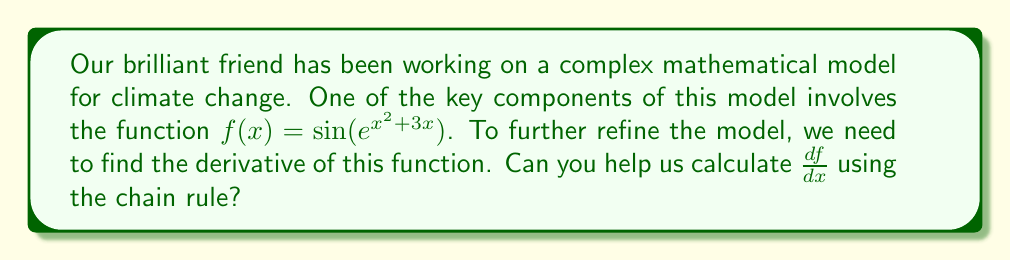Teach me how to tackle this problem. Let's approach this step-by-step using the chain rule:

1) First, we can rewrite the function as a composition of simpler functions:
   $f(x) = \sin(u)$, where $u = e^v$, and $v = x^2 + 3x$

2) Now, we'll apply the chain rule:
   $$\frac{df}{dx} = \frac{df}{du} \cdot \frac{du}{dv} \cdot \frac{dv}{dx}$$

3) Let's calculate each derivative:
   
   a) $\frac{df}{du} = \cos(u)$ (derivative of sine)
   
   b) $\frac{du}{dv} = e^v$ (derivative of exponential)
   
   c) $\frac{dv}{dx} = 2x + 3$ (derivative of $x^2 + 3x$)

4) Substituting these back into the chain rule:
   $$\frac{df}{dx} = \cos(u) \cdot e^v \cdot (2x + 3)$$

5) Now, let's substitute back the original expressions:
   $$\frac{df}{dx} = \cos(e^{x^2 + 3x}) \cdot e^{x^2 + 3x} \cdot (2x + 3)$$

6) This can be simplified to:
   $$\frac{df}{dx} = (2x + 3) \cdot e^{x^2 + 3x} \cdot \cos(e^{x^2 + 3x})$$

This is the final form of the derivative.
Answer: $\frac{df}{dx} = (2x + 3) \cdot e^{x^2 + 3x} \cdot \cos(e^{x^2 + 3x})$ 